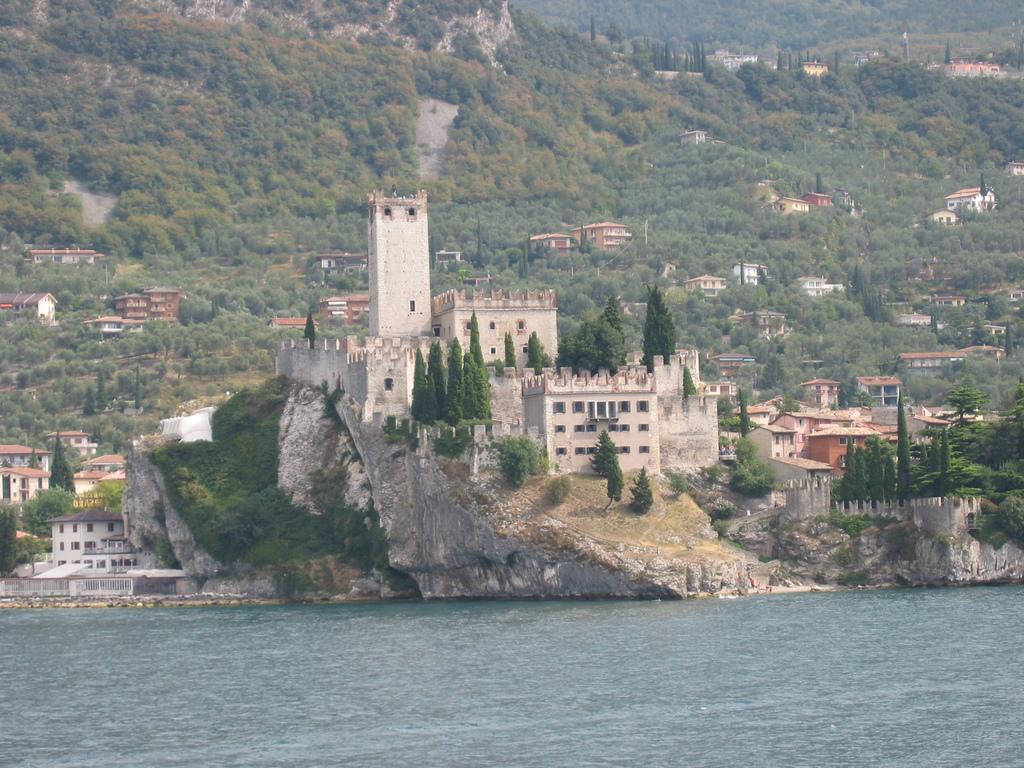In one or two sentences, can you explain what this image depicts? In this image I can see buildings. There are trees, rocks and there is water. 